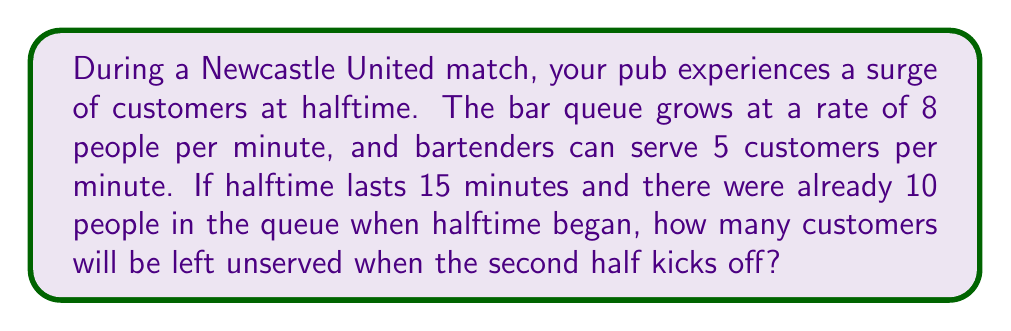Show me your answer to this math problem. Let's break this down step-by-step:

1) First, we need to calculate the net growth rate of the queue:
   Net growth rate = Arrival rate - Service rate
   $$ 8 - 5 = 3 \text{ people/minute} $$

2) Now, we can set up an equation for the total number of people in the queue after 15 minutes:
   $$ Q = 10 + 3t $$
   Where $Q$ is the number of people in the queue, 10 is the initial number of people, 3 is the net growth rate per minute, and $t$ is the time in minutes.

3) Substitute $t = 15$ (for 15 minutes of halftime):
   $$ Q = 10 + 3(15) = 10 + 45 = 55 \text{ people} $$

4) This means there will be 55 people in the queue at the end of halftime.

5) To find how many will be left unserved, we need to subtract the number of people served during halftime:
   Number served = Service rate × Time
   $$ 5 \text{ people/minute} \times 15 \text{ minutes} = 75 \text{ people} $$

6) However, we can't serve more people than are in the queue. Since only 55 people are in the queue, all of them will be served.

Therefore, 0 customers will be left unserved when the second half kicks off.
Answer: 0 customers 